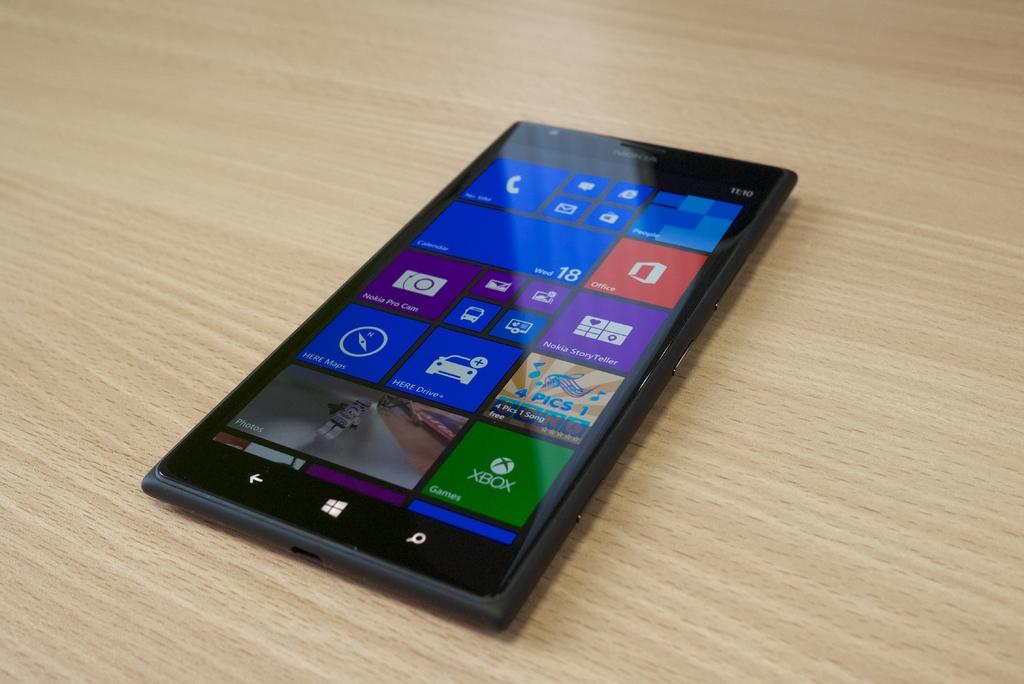<image>
Relay a brief, clear account of the picture shown. A smart device including an app for xbox in the lower right corner. 